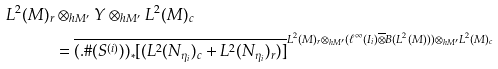Convert formula to latex. <formula><loc_0><loc_0><loc_500><loc_500>L ^ { 2 } ( M ) _ { r } & \otimes _ { h M ^ { \prime } } Y \otimes _ { h M ^ { \prime } } L ^ { 2 } ( M ) _ { c } \\ & = \overline { ( . \# ( S ^ { ( i ) } ) ) _ { * } [ ( L ^ { 2 } ( N _ { \eta _ { i } } ) _ { c } + L ^ { 2 } ( N _ { \eta _ { i } } ) _ { r } ) ] } ^ { L ^ { 2 } ( M ) _ { r } \otimes _ { h M ^ { \prime } } ( \ell ^ { \infty } ( I _ { i } ) \overline { \otimes } B ( L ^ { 2 } ( M ) ) ) \otimes _ { h M ^ { \prime } } L ^ { 2 } ( M ) _ { c } }</formula> 